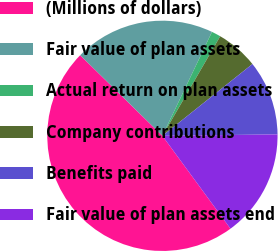Convert chart to OTSL. <chart><loc_0><loc_0><loc_500><loc_500><pie_chart><fcel>(Millions of dollars)<fcel>Fair value of plan assets<fcel>Actual return on plan assets<fcel>Company contributions<fcel>Benefits paid<fcel>Fair value of plan assets end<nl><fcel>47.41%<fcel>19.74%<fcel>1.29%<fcel>5.91%<fcel>10.52%<fcel>15.13%<nl></chart> 